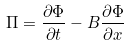Convert formula to latex. <formula><loc_0><loc_0><loc_500><loc_500>\Pi = \frac { \partial \Phi } { \partial t } - B \frac { \partial \Phi } { \partial x }</formula> 